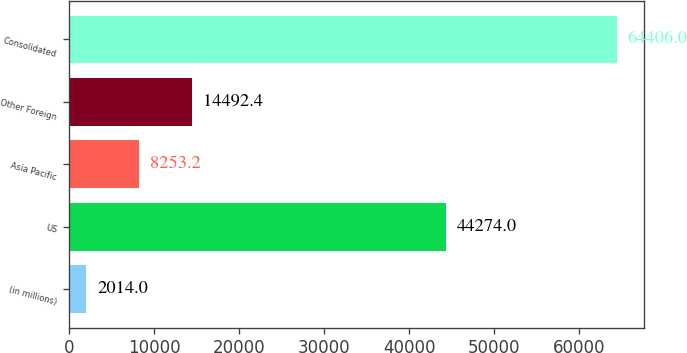Convert chart. <chart><loc_0><loc_0><loc_500><loc_500><bar_chart><fcel>(in millions)<fcel>US<fcel>Asia Pacific<fcel>Other Foreign<fcel>Consolidated<nl><fcel>2014<fcel>44274<fcel>8253.2<fcel>14492.4<fcel>64406<nl></chart> 